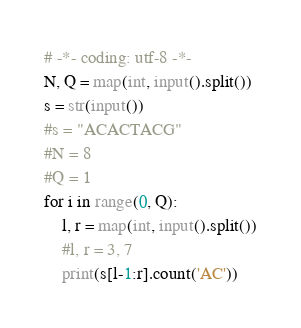Convert code to text. <code><loc_0><loc_0><loc_500><loc_500><_Python_># -*- coding: utf-8 -*-
N, Q = map(int, input().split())
s = str(input())
#s = "ACACTACG"
#N = 8
#Q = 1
for i in range(0, Q):
    l, r = map(int, input().split())
    #l, r = 3, 7
    print(s[l-1:r].count('AC'))</code> 